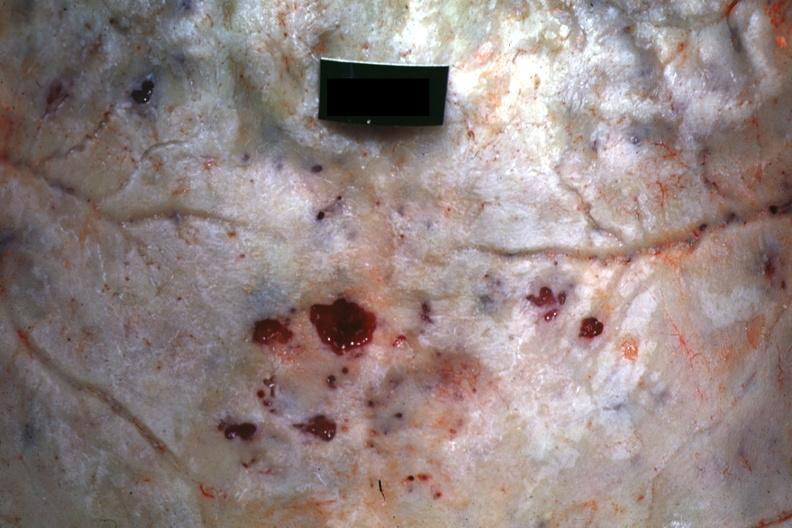what is present?
Answer the question using a single word or phrase. Bone, skull 